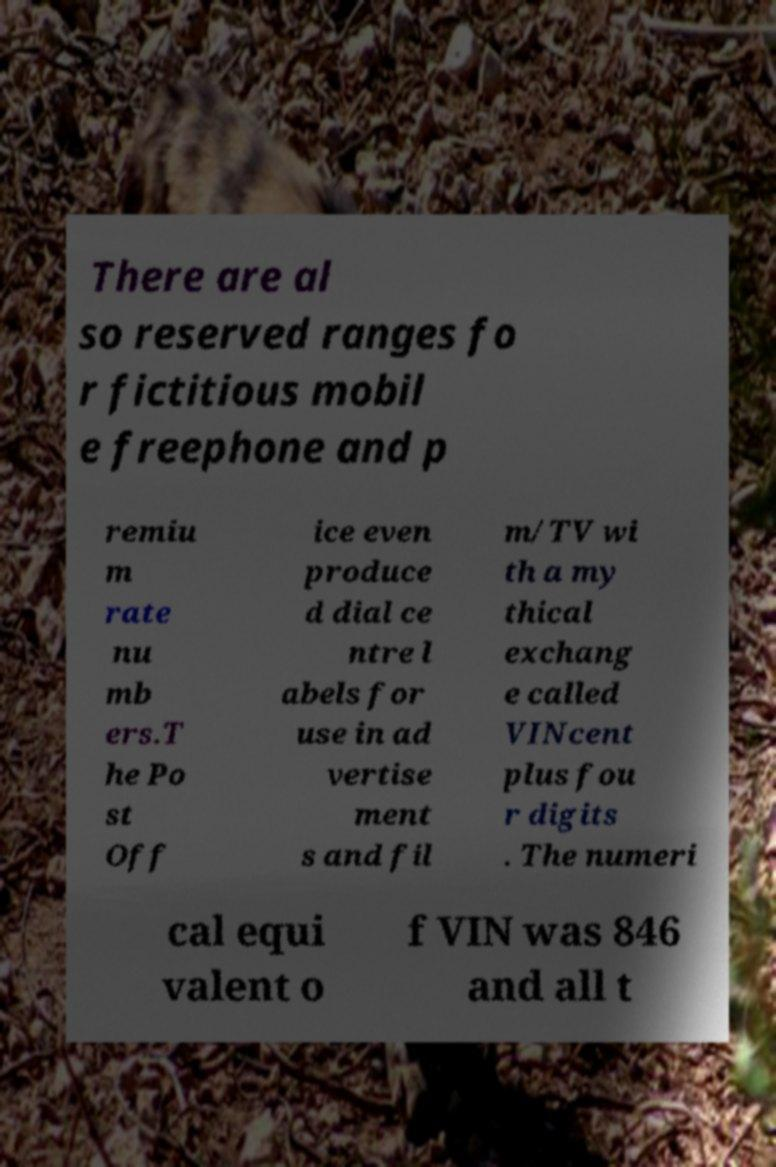Please read and relay the text visible in this image. What does it say? There are al so reserved ranges fo r fictitious mobil e freephone and p remiu m rate nu mb ers.T he Po st Off ice even produce d dial ce ntre l abels for use in ad vertise ment s and fil m/TV wi th a my thical exchang e called VINcent plus fou r digits . The numeri cal equi valent o f VIN was 846 and all t 